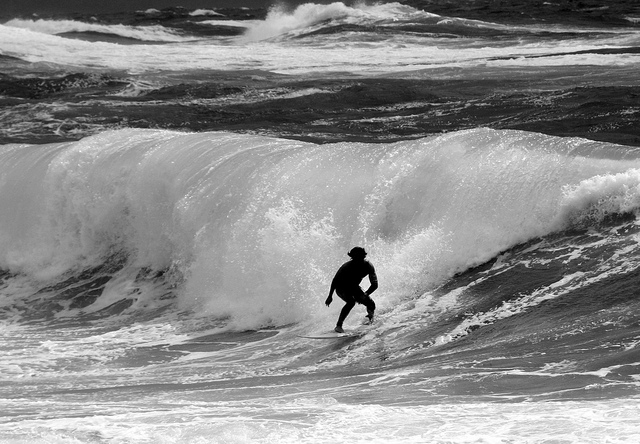Can you tell is this is a man or woman? The individual's gender cannot be reliably determined from this image due to the wetsuit and position on the surfboard obscuring distinctive features. 